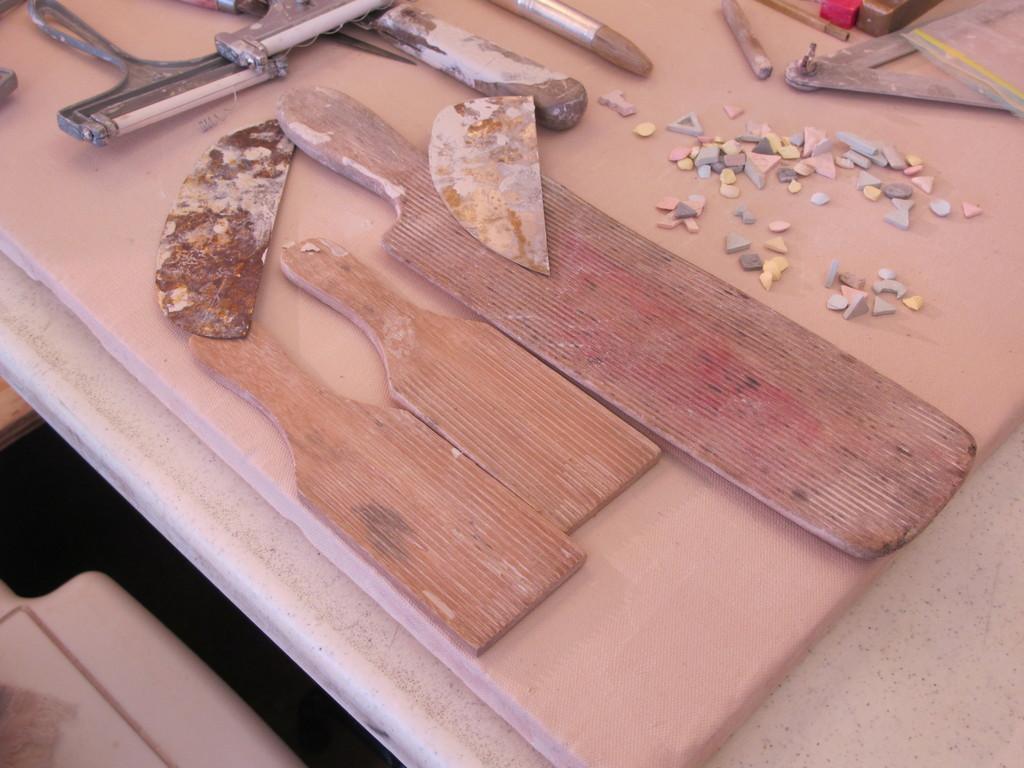Can you describe this image briefly? In this picture I can see the wooden objects, metal objects, plastic objects. I can see tiny objects on the right side. 